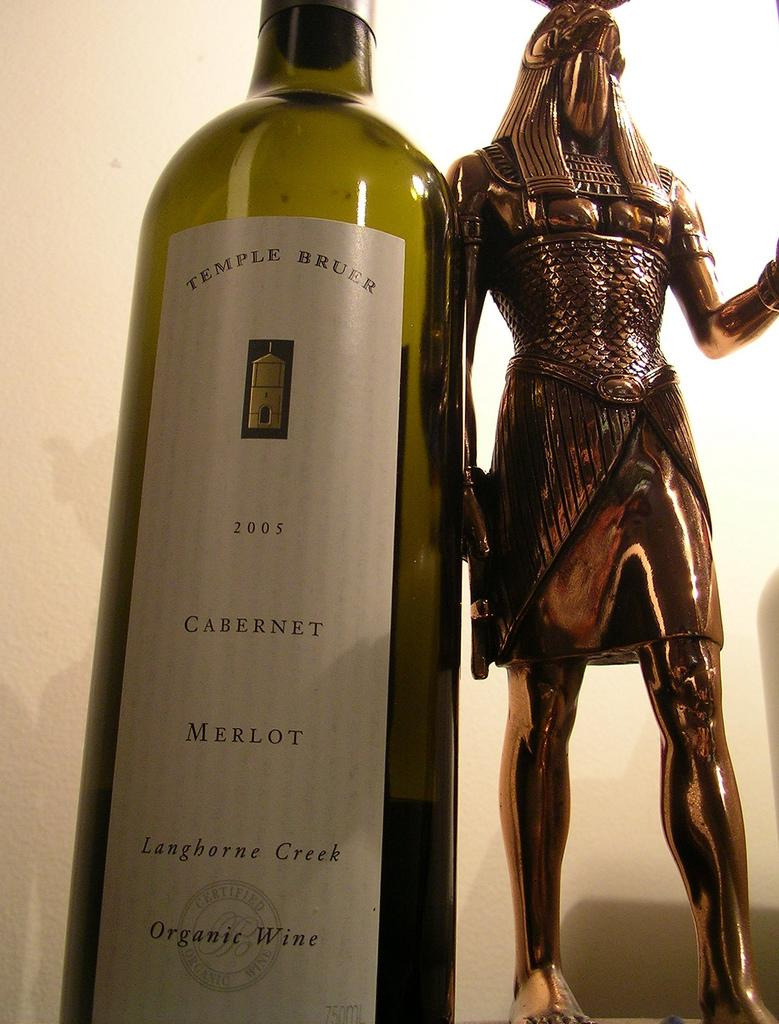<image>
Write a terse but informative summary of the picture. A bottle of Temple Bruer 2005 Cabernet Merlot sits next to a statue. 